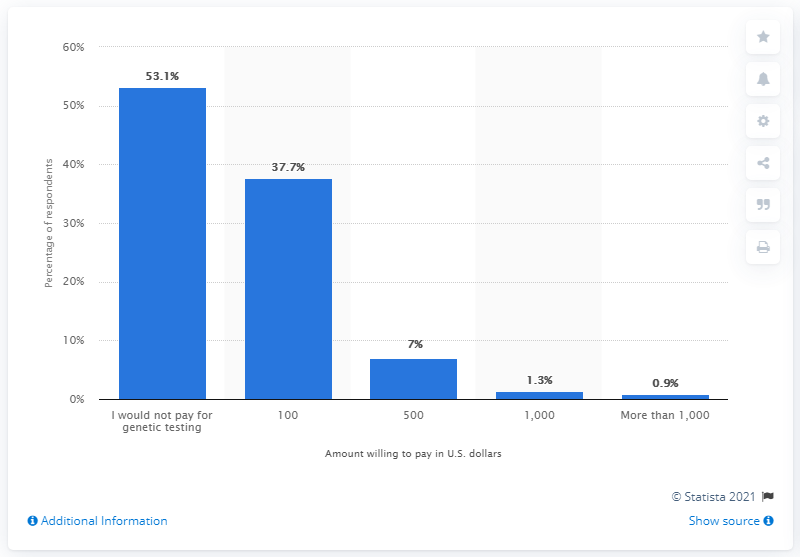What source is provided for the information in this chart? The information in the chart comes from Statista, a reputable statistics company known for providing reliable data. The chart is marked with '© Statista 2021' at the bottom, indicating their ownership of the data for that year. 